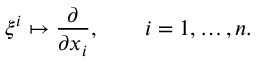Convert formula to latex. <formula><loc_0><loc_0><loc_500><loc_500>\xi ^ { i } \mapsto \frac { \partial } { \partial x _ { i } } , \quad i = 1 , \dots , n .</formula> 